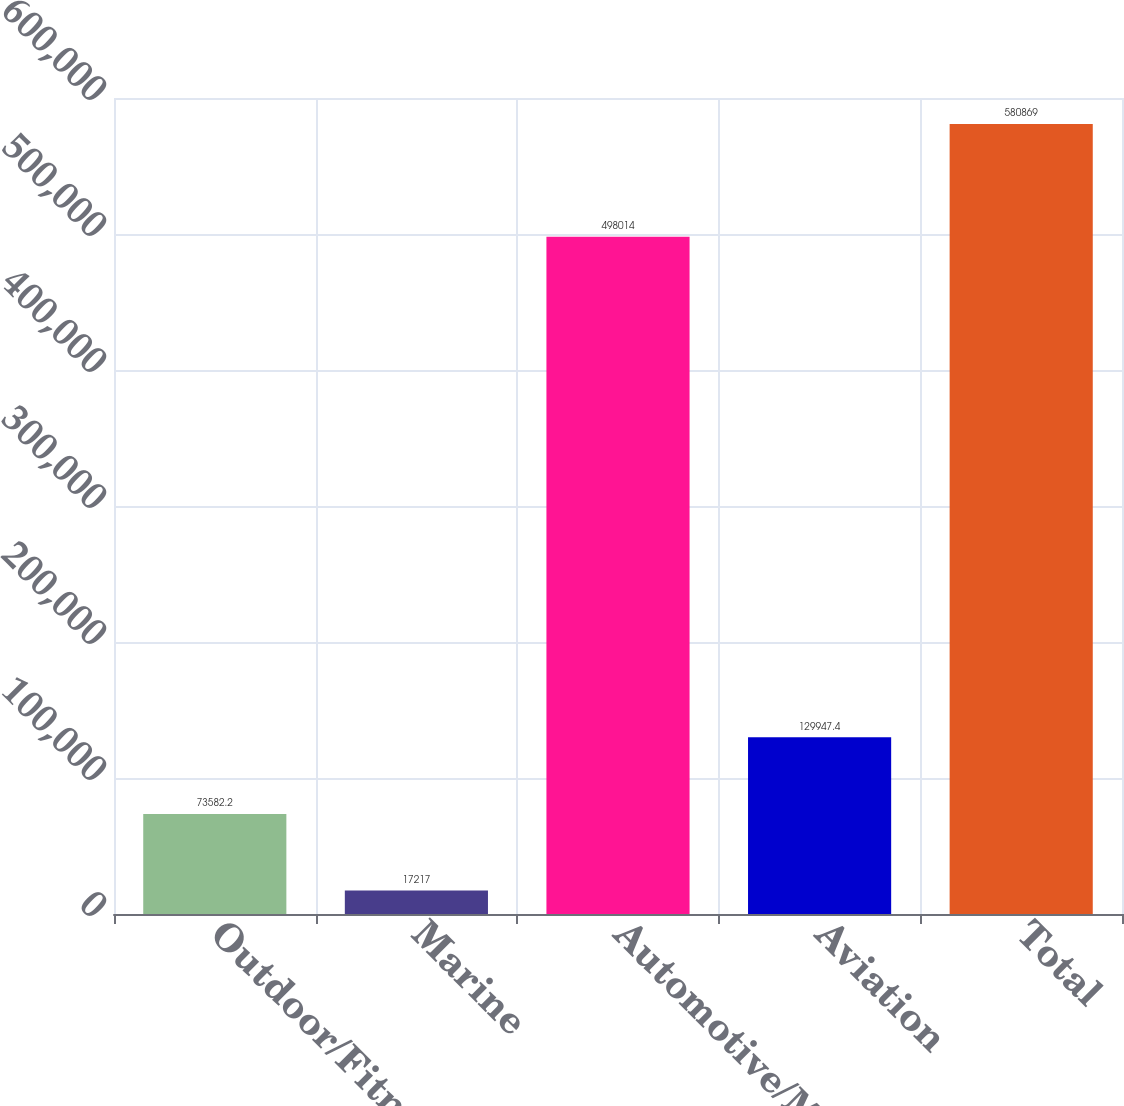Convert chart to OTSL. <chart><loc_0><loc_0><loc_500><loc_500><bar_chart><fcel>Outdoor/Fitness<fcel>Marine<fcel>Automotive/Mobile<fcel>Aviation<fcel>Total<nl><fcel>73582.2<fcel>17217<fcel>498014<fcel>129947<fcel>580869<nl></chart> 